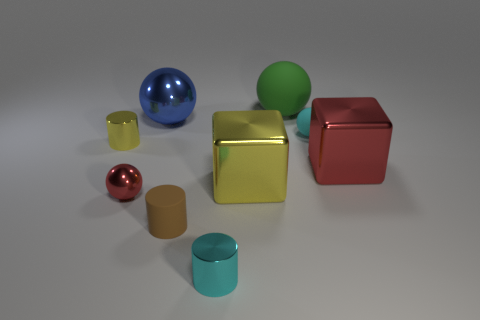Subtract 1 balls. How many balls are left? 3 Subtract all blue spheres. Subtract all blue blocks. How many spheres are left? 3 Add 1 large metal blocks. How many objects exist? 10 Subtract all spheres. How many objects are left? 5 Add 5 tiny yellow things. How many tiny yellow things exist? 6 Subtract 0 green cylinders. How many objects are left? 9 Subtract all small brown matte cubes. Subtract all tiny yellow cylinders. How many objects are left? 8 Add 3 tiny brown cylinders. How many tiny brown cylinders are left? 4 